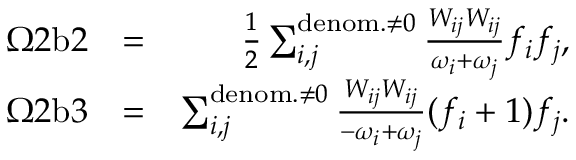Convert formula to latex. <formula><loc_0><loc_0><loc_500><loc_500>\begin{array} { r l r } { \Omega 2 b 2 } & { = } & { \frac { 1 } { 2 } \sum _ { i , j } ^ { d e n o m . \neq 0 } \frac { W _ { i j } W _ { i j } } { \omega _ { i } + \omega _ { j } } f _ { i } f _ { j } , } \\ { \Omega 2 b 3 } & { = } & { \sum _ { i , j } ^ { d e n o m . \neq 0 } \frac { W _ { i j } W _ { i j } } { - \omega _ { i } + \omega _ { j } } ( f _ { i } + 1 ) f _ { j } . } \end{array}</formula> 